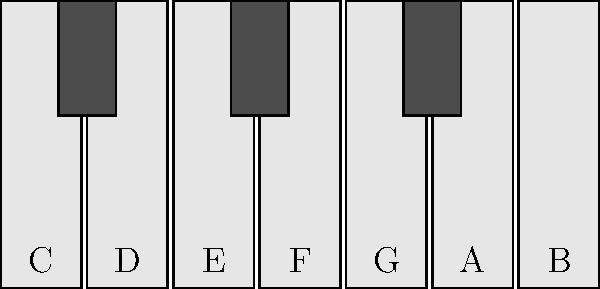Consider the simplified piano keyboard layout shown above, representing one octave. What is the order of the symmetry group of this pattern, considering only horizontal reflections and rotations? To determine the order of the symmetry group, we need to identify all the symmetry operations that leave the pattern unchanged. Let's approach this step-by-step:

1. Rotational symmetry:
   The pattern has no rotational symmetry other than the identity rotation (360°), as rotating it by any other angle would change the arrangement of black and white keys.

2. Reflection symmetry:
   There is one line of reflection symmetry, which is the vertical line passing through the middle of the F key.

3. Counting symmetries:
   - Identity operation (do nothing): 1
   - Reflection about the vertical line through F: 1

4. Calculating the order:
   The order of the symmetry group is the total number of distinct symmetry operations.
   In this case, 1 (identity) + 1 (reflection) = 2

Therefore, the symmetry group of this piano key pattern has an order of 2, which corresponds to the cyclic group $C_2$ or the dihedral group $D_1$.

This result aligns well with the classical music perspective, as it reflects the fundamental structure of the diatonic scale, which is central to Western classical music theory.
Answer: 2 